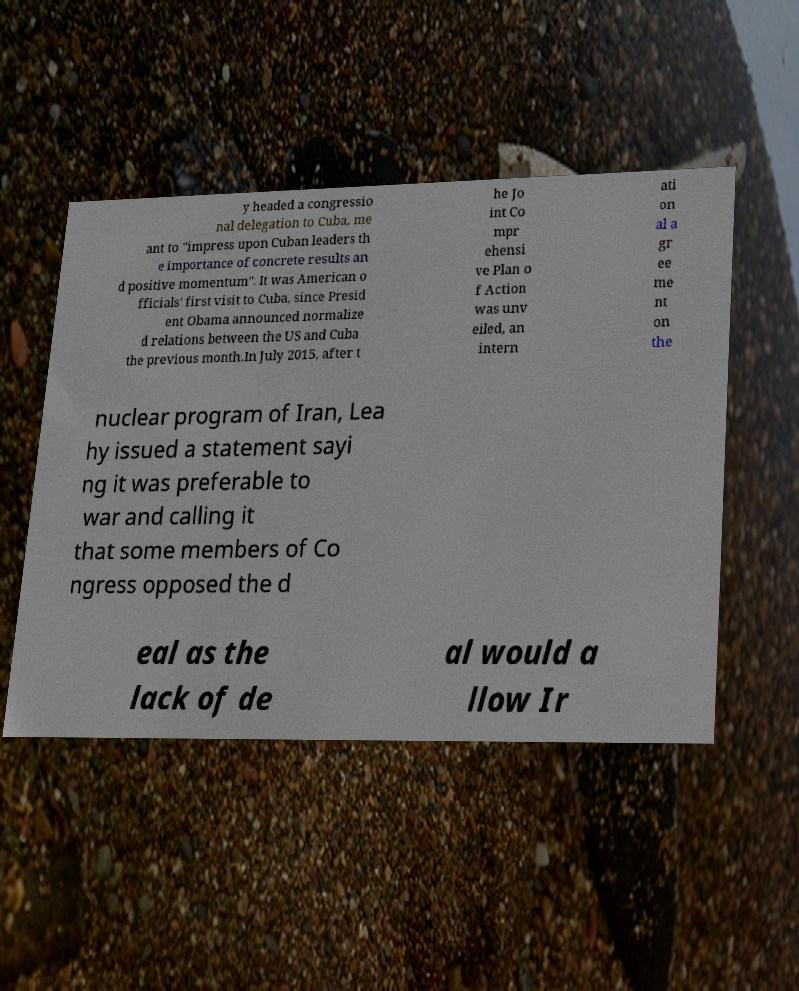For documentation purposes, I need the text within this image transcribed. Could you provide that? y headed a congressio nal delegation to Cuba, me ant to "impress upon Cuban leaders th e importance of concrete results an d positive momentum". It was American o fficials' first visit to Cuba, since Presid ent Obama announced normalize d relations between the US and Cuba the previous month.In July 2015, after t he Jo int Co mpr ehensi ve Plan o f Action was unv eiled, an intern ati on al a gr ee me nt on the nuclear program of Iran, Lea hy issued a statement sayi ng it was preferable to war and calling it that some members of Co ngress opposed the d eal as the lack of de al would a llow Ir 